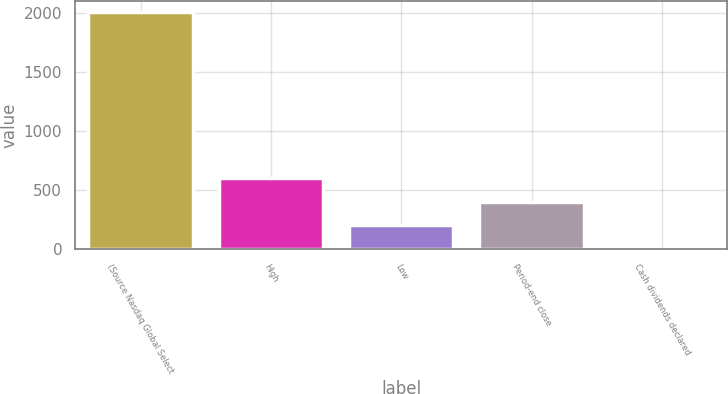<chart> <loc_0><loc_0><loc_500><loc_500><bar_chart><fcel>(Source Nasdaq Global Select<fcel>High<fcel>Low<fcel>Period-end close<fcel>Cash dividends declared<nl><fcel>2005<fcel>601.71<fcel>200.77<fcel>401.24<fcel>0.3<nl></chart> 